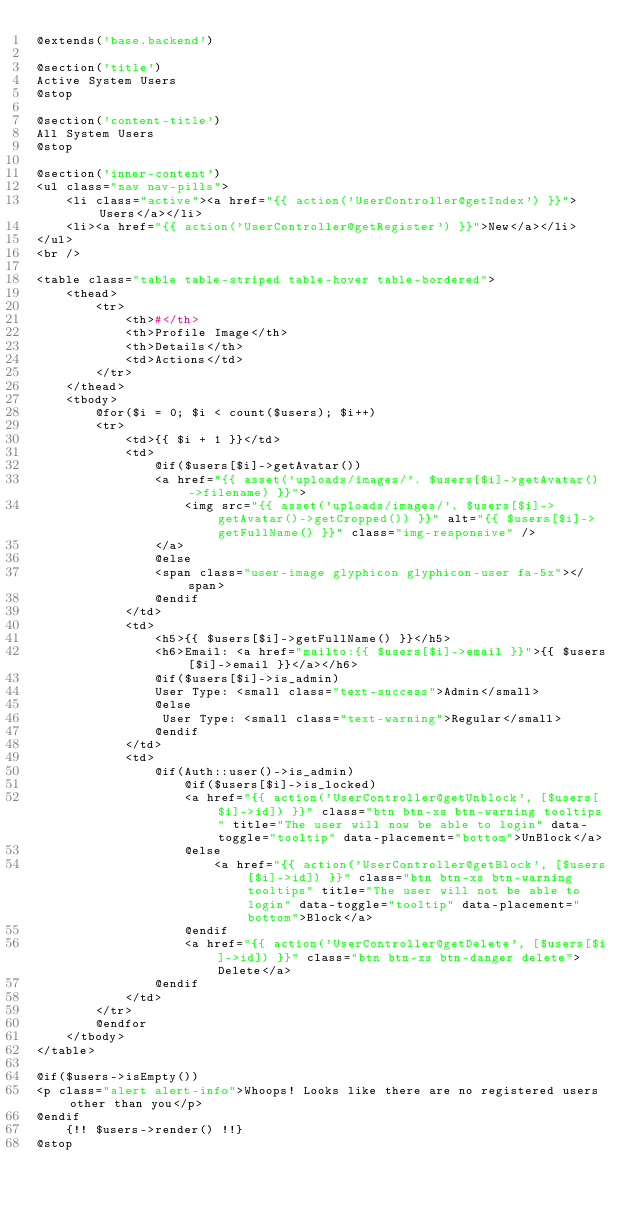Convert code to text. <code><loc_0><loc_0><loc_500><loc_500><_PHP_>@extends('base.backend')

@section('title')
Active System Users
@stop

@section('content-title')
All System Users
@stop

@section('inner-content')
<ul class="nav nav-pills">
    <li class="active"><a href="{{ action('UserController@getIndex') }}">Users</a></li>
    <li><a href="{{ action('UserController@getRegister') }}">New</a></li>
</ul>
<br />

<table class="table table-striped table-hover table-bordered">
    <thead>
        <tr>
            <th>#</th>
            <th>Profile Image</th>
            <th>Details</th>
            <td>Actions</td>
        </tr>
    </thead>
    <tbody>
        @for($i = 0; $i < count($users); $i++)
        <tr>
            <td>{{ $i + 1 }}</td>
            <td>
                @if($users[$i]->getAvatar())
                <a href="{{ asset('uploads/images/'. $users[$i]->getAvatar()->filename) }}">
                    <img src="{{ asset('uploads/images/'. $users[$i]->getAvatar()->getCropped()) }}" alt="{{ $users[$i]->getFullName() }}" class="img-responsive" />
                </a>
                @else
                <span class="user-image glyphicon glyphicon-user fa-5x"></span>
                @endif
            </td>
            <td>
                <h5>{{ $users[$i]->getFullName() }}</h5>
                <h6>Email: <a href="mailto:{{ $users[$i]->email }}">{{ $users[$i]->email }}</a></h6>
                @if($users[$i]->is_admin)
                User Type: <small class="text-success">Admin</small>
                @else
                 User Type: <small class="text-warning">Regular</small>
                @endif
            </td>
            <td>
                @if(Auth::user()->is_admin)
                    @if($users[$i]->is_locked)
                    <a href="{{ action('UserController@getUnblock', [$users[$i]->id]) }}" class="btn btn-xs btn-warning tooltips" title="The user will now be able to login" data-toggle="tooltip" data-placement="bottom">UnBlock</a>
                    @else
                        <a href="{{ action('UserController@getBlock', [$users[$i]->id]) }}" class="btn btn-xs btn-warning tooltips" title="The user will not be able to login" data-toggle="tooltip" data-placement="bottom">Block</a>
                    @endif
                    <a href="{{ action('UserController@getDelete', [$users[$i]->id]) }}" class="btn btn-xs btn-danger delete">Delete</a>
                @endif
            </td>
        </tr>
        @endfor
    </tbody>
</table>
    
@if($users->isEmpty())
<p class="alert alert-info">Whoops! Looks like there are no registered users other than you</p>
@endif
    {!! $users->render() !!}
@stop
</code> 